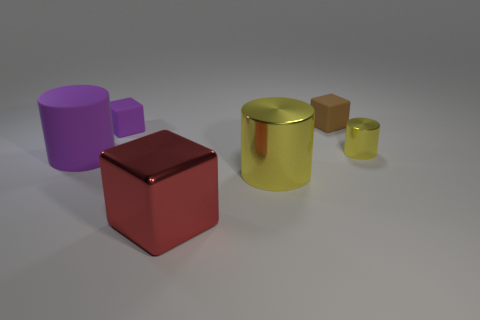Do the rubber cylinder and the purple cube have the same size?
Provide a succinct answer. No. What color is the large cylinder that is made of the same material as the small yellow cylinder?
Keep it short and to the point. Yellow. What is the shape of the object that is the same color as the tiny metallic cylinder?
Make the answer very short. Cylinder. Are there the same number of big red metal things behind the large yellow metallic thing and small brown things that are on the left side of the matte cylinder?
Provide a succinct answer. Yes. There is a shiny thing on the right side of the rubber cube that is on the right side of the large red metallic object; what is its shape?
Offer a terse response. Cylinder. There is a small yellow thing that is the same shape as the large purple matte thing; what is it made of?
Your answer should be compact. Metal. There is a metal cylinder that is the same size as the brown object; what color is it?
Offer a terse response. Yellow. Are there an equal number of brown things that are in front of the big yellow cylinder and cyan rubber cubes?
Provide a succinct answer. Yes. There is a large cylinder right of the purple matte object that is right of the big rubber object; what color is it?
Give a very brief answer. Yellow. What size is the purple rubber thing on the left side of the rubber block left of the big red thing?
Your response must be concise. Large. 